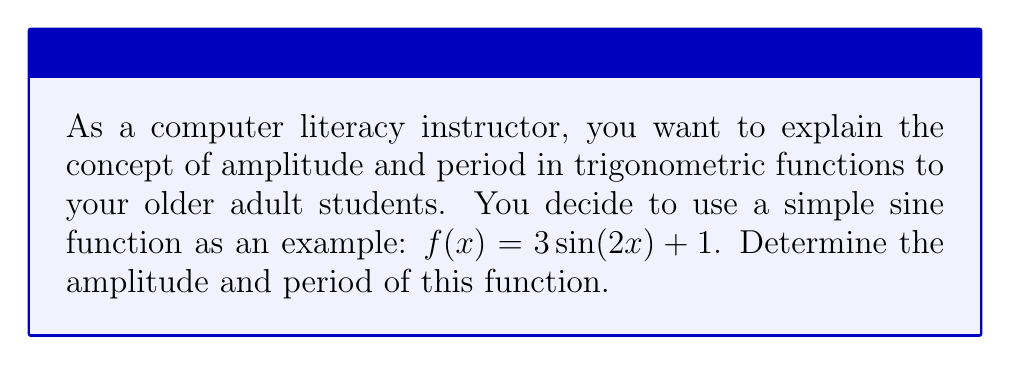Solve this math problem. Let's break this down step-by-step:

1) The general form of a sine function is:
   $f(x) = A\sin(Bx) + C$
   where $A$ is the amplitude, $B$ affects the period, and $C$ is the vertical shift.

2) In our function $f(x) = 3\sin(2x) + 1$:
   $A = 3$
   $B = 2$
   $C = 1$

3) Amplitude:
   The amplitude is the absolute value of $A$.
   Amplitude $= |A| = |3| = 3$

4) Period:
   For a sine function, the period is given by the formula:
   Period $= \frac{2\pi}{|B|}$

   In this case:
   Period $= \frac{2\pi}{|2|} = \frac{2\pi}{2} = \pi$

5) To help visualize this, we can think of the function as stretching the normal sine curve vertically by a factor of 3, compressing it horizontally to half its normal width, and then shifting it up by 1 unit.
Answer: Amplitude: 3, Period: $\pi$ 